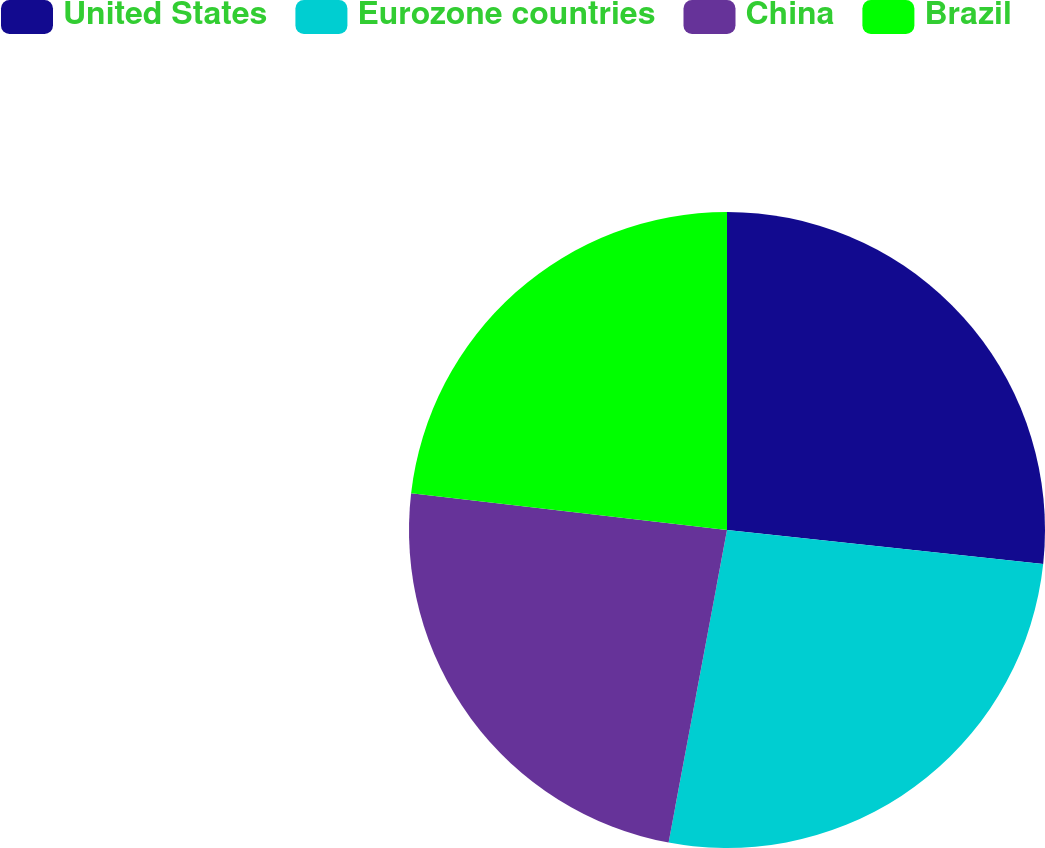<chart> <loc_0><loc_0><loc_500><loc_500><pie_chart><fcel>United States<fcel>Eurozone countries<fcel>China<fcel>Brazil<nl><fcel>26.7%<fcel>26.24%<fcel>23.9%<fcel>23.16%<nl></chart> 